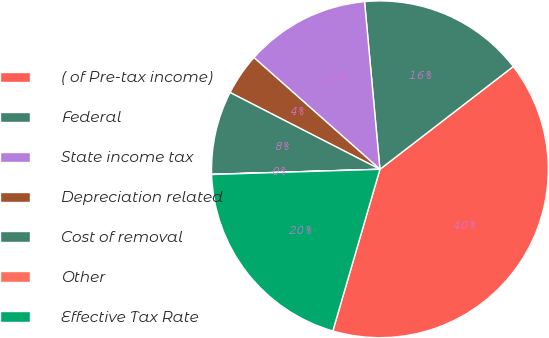Convert chart to OTSL. <chart><loc_0><loc_0><loc_500><loc_500><pie_chart><fcel>( of Pre-tax income)<fcel>Federal<fcel>State income tax<fcel>Depreciation related<fcel>Cost of removal<fcel>Other<fcel>Effective Tax Rate<nl><fcel>39.96%<fcel>16.0%<fcel>12.0%<fcel>4.01%<fcel>8.01%<fcel>0.02%<fcel>19.99%<nl></chart> 